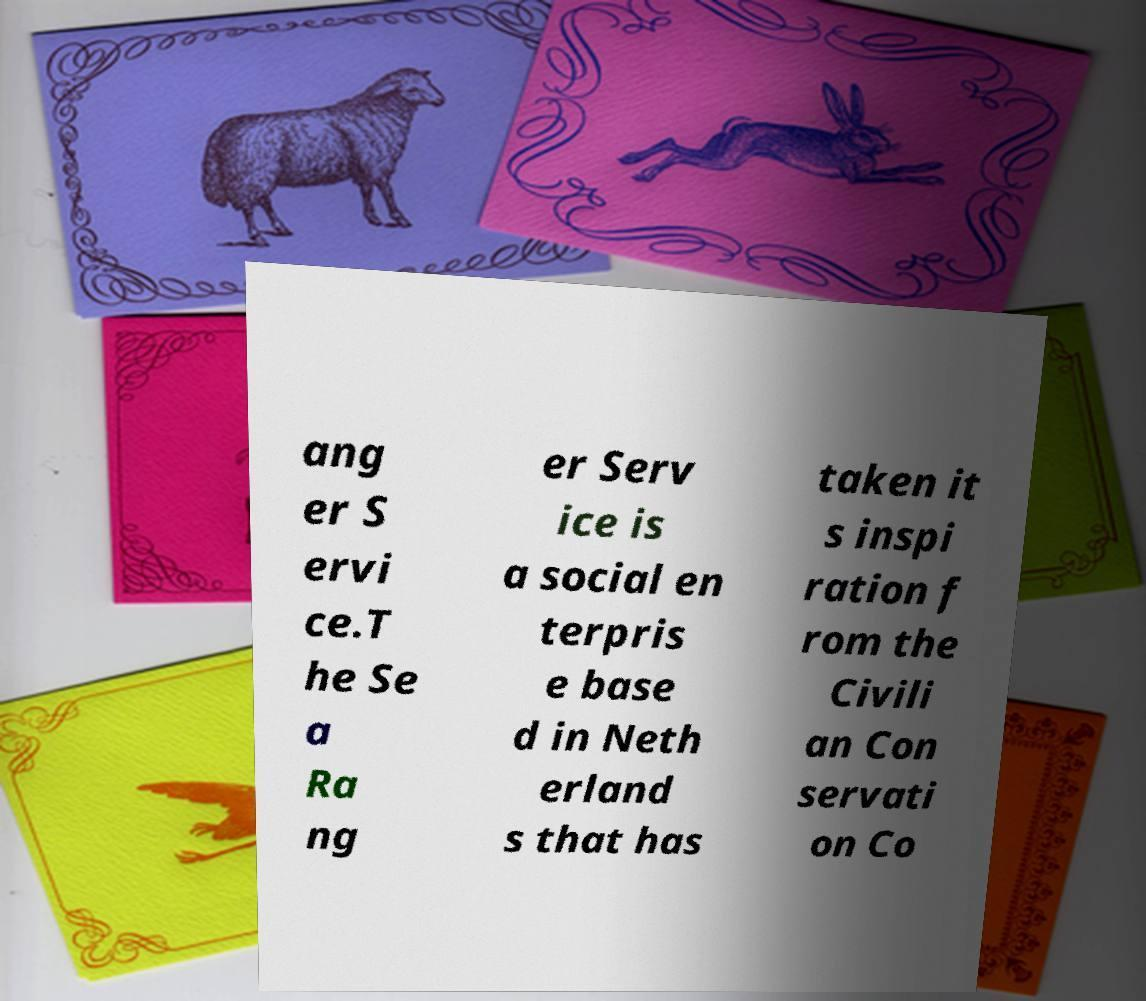Could you assist in decoding the text presented in this image and type it out clearly? ang er S ervi ce.T he Se a Ra ng er Serv ice is a social en terpris e base d in Neth erland s that has taken it s inspi ration f rom the Civili an Con servati on Co 